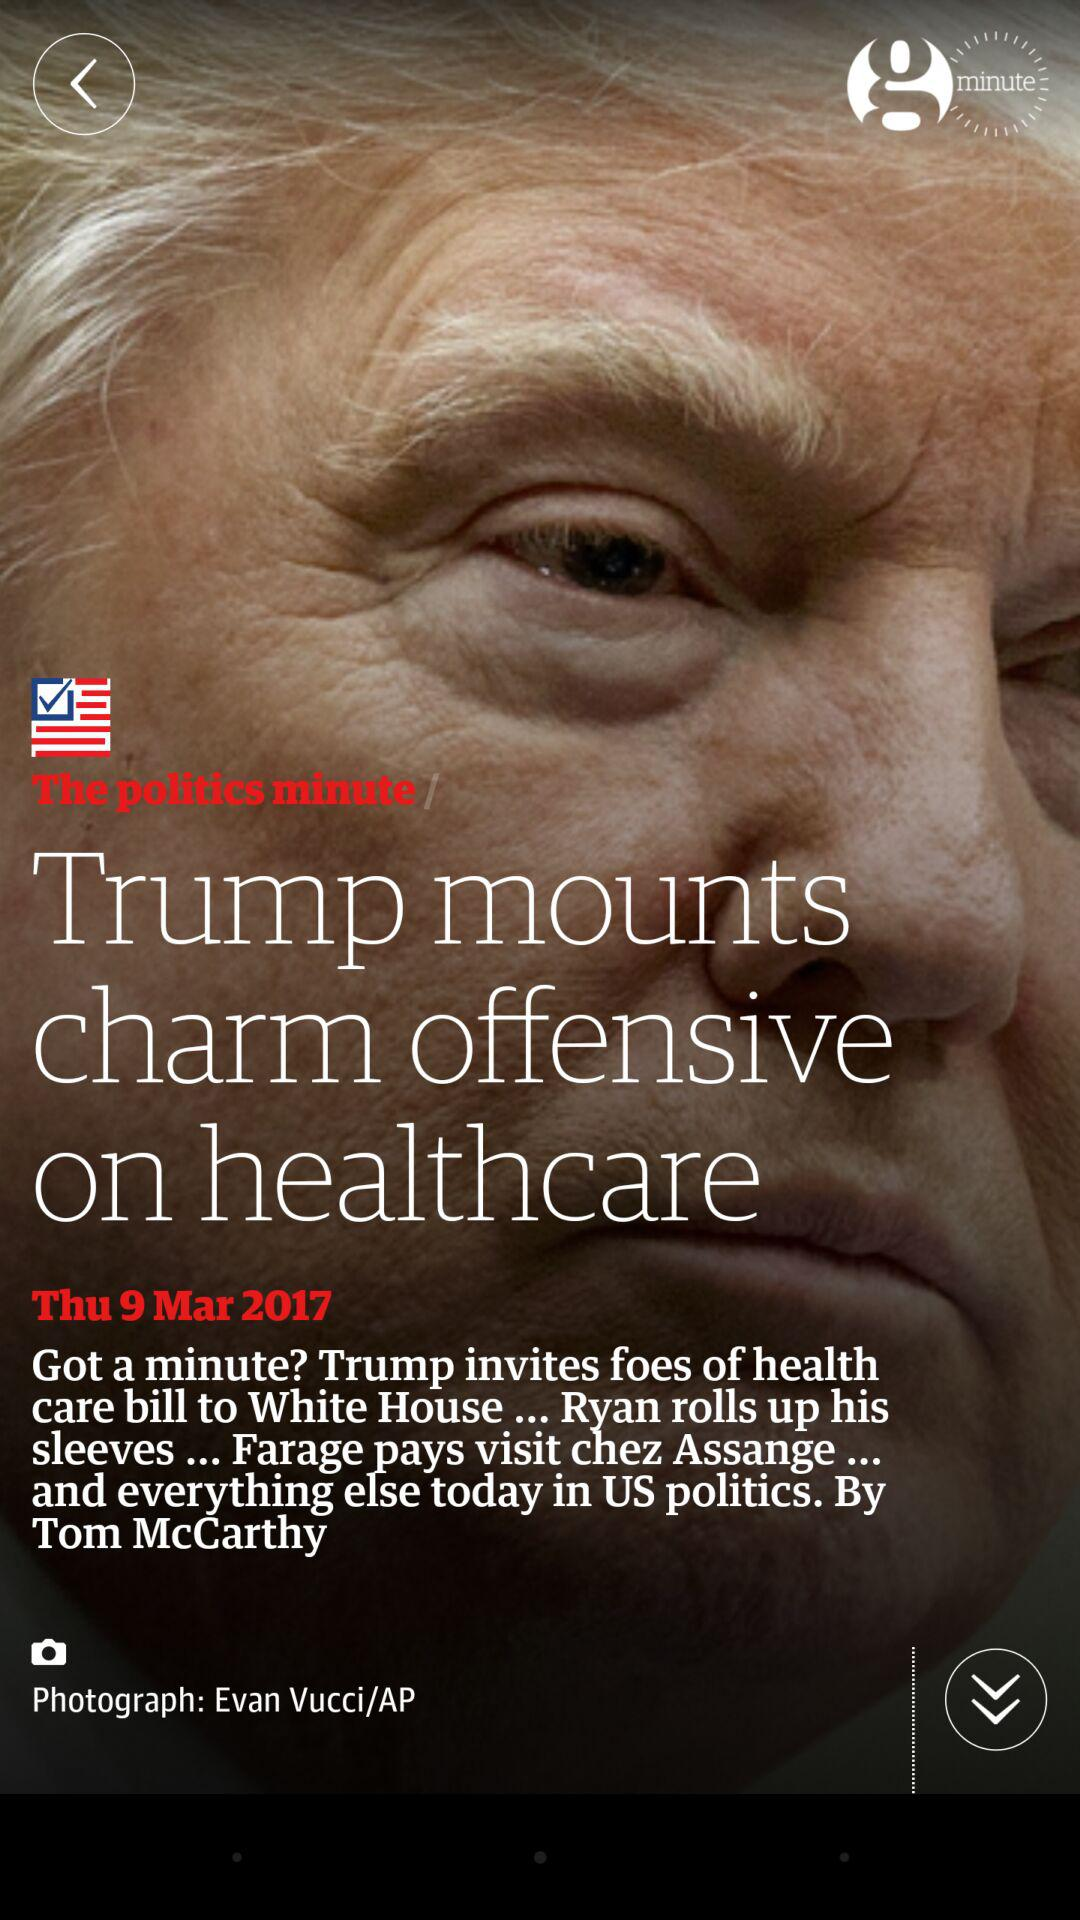What is the photographer name? The photographer name is Evan Vucci. 